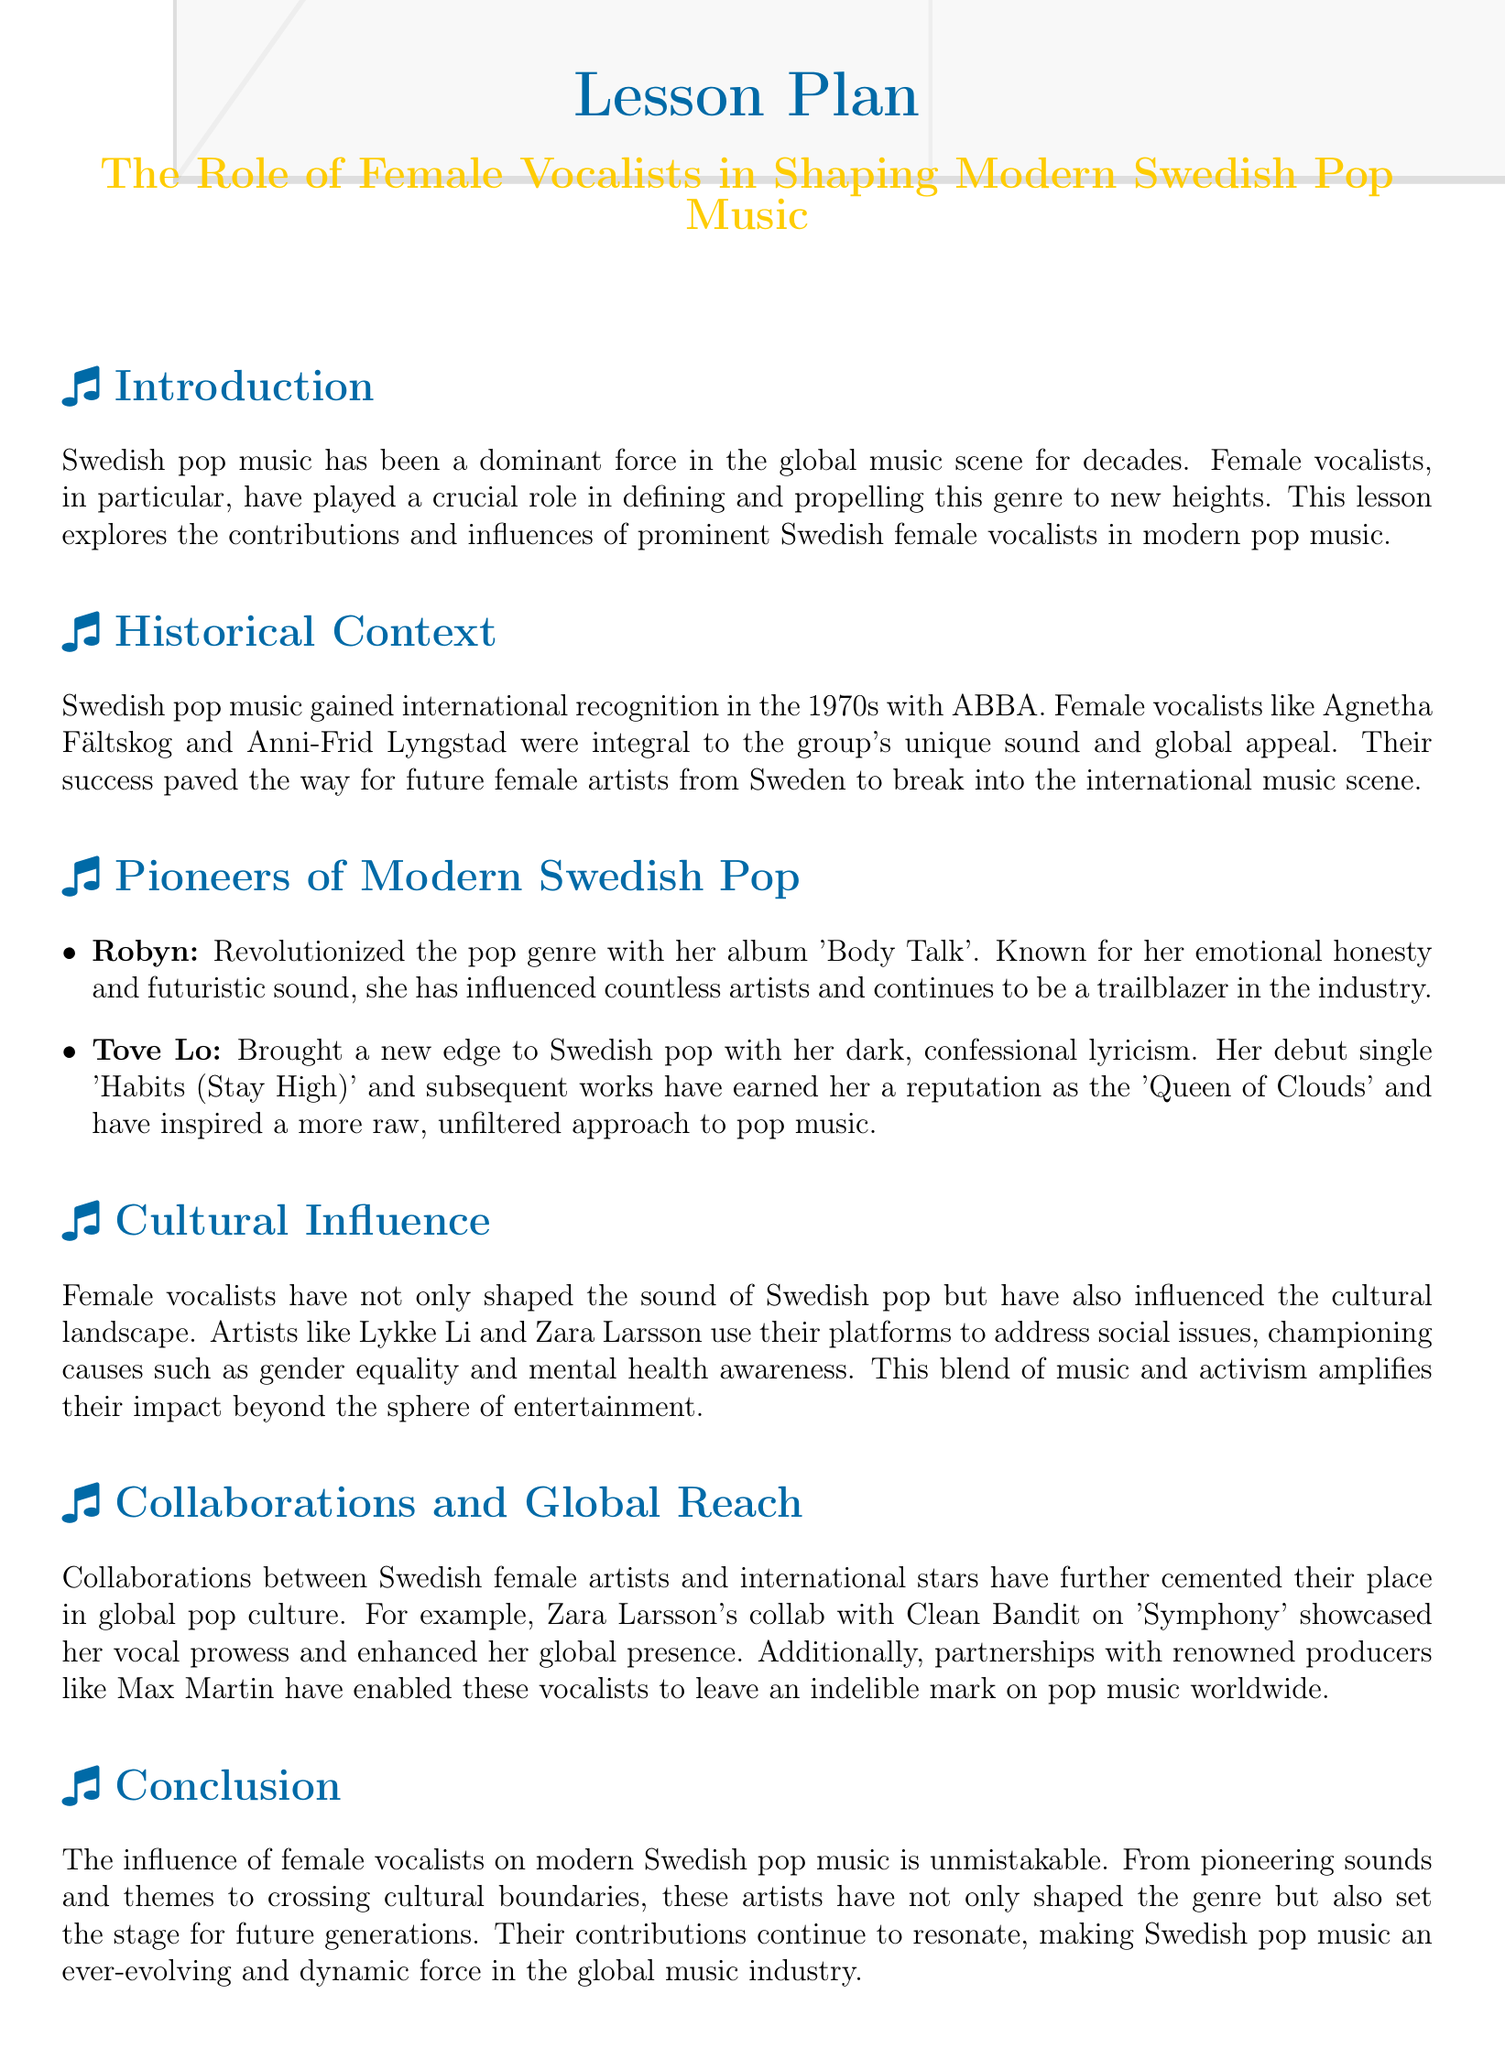What is the title of the lesson plan? The title is presented prominently at the beginning of the document, indicating the focus of the lesson.
Answer: The Role of Female Vocalists in Shaping Modern Swedish Pop Music Who were the female vocalists in ABBA? The document specifically names the female vocalists who were part of the influential group ABBA, showcasing their importance.
Answer: Agnetha Fältskog and Anni-Frid Lyngstad Which artist is known for her album 'Body Talk'? The document highlights a specific artist who has made significant contributions to modern pop music with this album.
Answer: Robyn What is Tove Lo's debut single? This information is mentioned when discussing Tove Lo's impact on Swedish pop music, providing insight into her early work.
Answer: Habits (Stay High) What cause does Lykke Li champion? The document notes the social issues addressed by female vocalists, including Lykke Li's engagement in these themes.
Answer: Gender equality How did Zara Larsson enhance her global presence? The document describes her collaboration that showcased her vocal skills, highlighting her influence in the global music scene.
Answer: Clean Bandit on 'Symphony' What is the impact of female vocalists on Swedish pop music according to the document? This impact is summarized at the end of the document, conveying the overarching theme of the lesson.
Answer: Unmistakable Who is referred to as the 'Queen of Clouds'? The document offers a unique title given to one of the discussed artists, which reflects her identity in the music industry.
Answer: Tove Lo What decade did Swedish pop music gain international recognition? This key information provides a historical context to the discussion of female vocalists and the evolution of the genre.
Answer: 1970s 